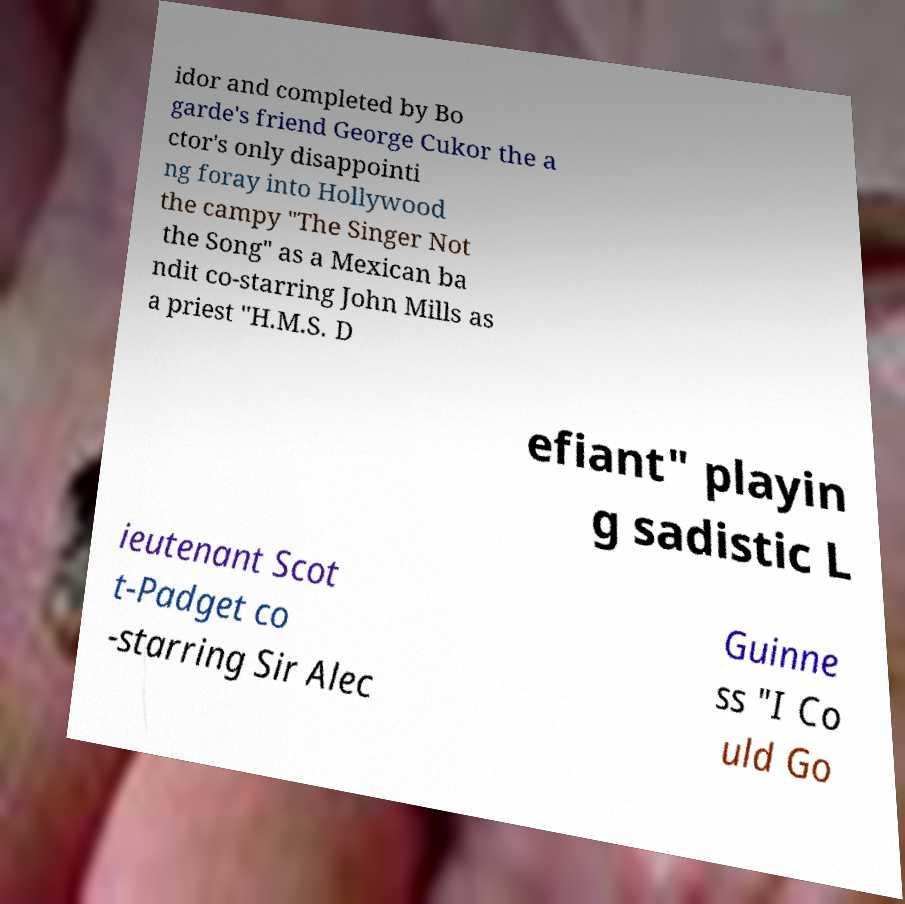What messages or text are displayed in this image? I need them in a readable, typed format. idor and completed by Bo garde's friend George Cukor the a ctor's only disappointi ng foray into Hollywood the campy "The Singer Not the Song" as a Mexican ba ndit co-starring John Mills as a priest "H.M.S. D efiant" playin g sadistic L ieutenant Scot t-Padget co -starring Sir Alec Guinne ss "I Co uld Go 